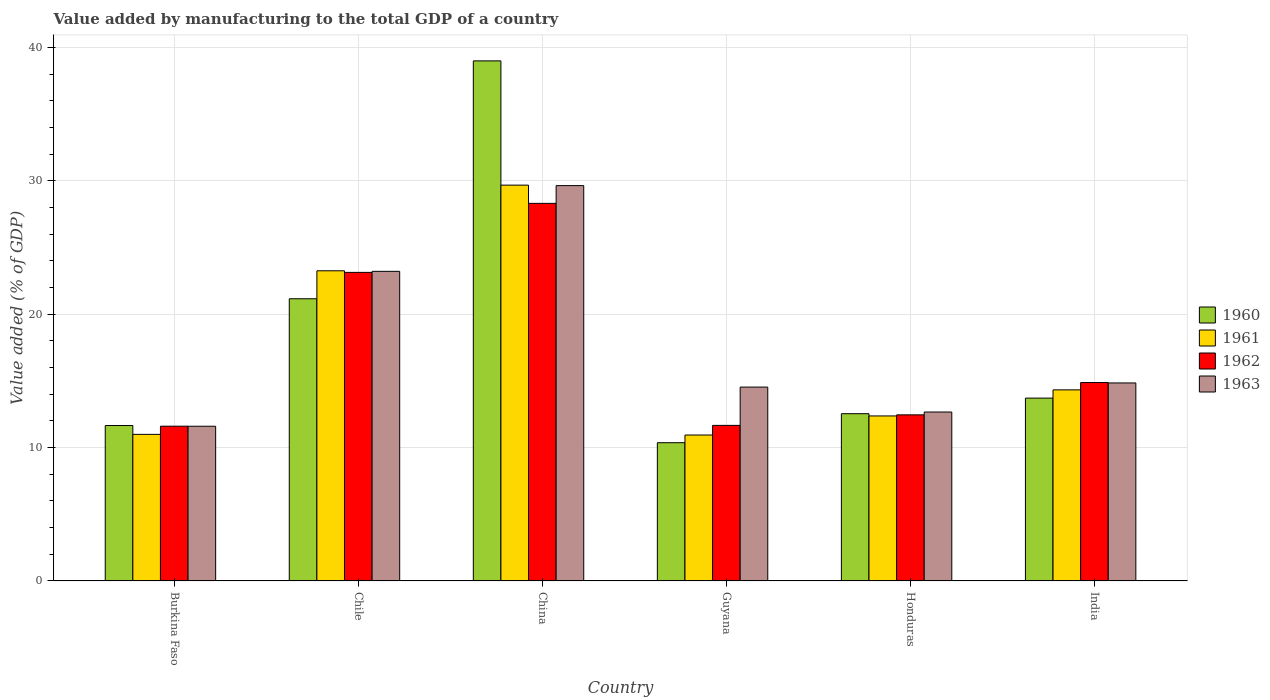How many different coloured bars are there?
Provide a short and direct response. 4. How many groups of bars are there?
Provide a succinct answer. 6. What is the label of the 1st group of bars from the left?
Give a very brief answer. Burkina Faso. What is the value added by manufacturing to the total GDP in 1963 in Burkina Faso?
Your answer should be very brief. 11.6. Across all countries, what is the maximum value added by manufacturing to the total GDP in 1963?
Your answer should be compact. 29.64. Across all countries, what is the minimum value added by manufacturing to the total GDP in 1962?
Offer a terse response. 11.6. In which country was the value added by manufacturing to the total GDP in 1961 minimum?
Offer a very short reply. Guyana. What is the total value added by manufacturing to the total GDP in 1960 in the graph?
Make the answer very short. 108.43. What is the difference between the value added by manufacturing to the total GDP in 1961 in Chile and that in Guyana?
Provide a succinct answer. 12.32. What is the difference between the value added by manufacturing to the total GDP in 1961 in Guyana and the value added by manufacturing to the total GDP in 1963 in India?
Provide a succinct answer. -3.91. What is the average value added by manufacturing to the total GDP in 1961 per country?
Make the answer very short. 16.93. What is the difference between the value added by manufacturing to the total GDP of/in 1963 and value added by manufacturing to the total GDP of/in 1960 in Burkina Faso?
Your answer should be very brief. -0.05. In how many countries, is the value added by manufacturing to the total GDP in 1962 greater than 14 %?
Provide a succinct answer. 3. What is the ratio of the value added by manufacturing to the total GDP in 1962 in Burkina Faso to that in Honduras?
Offer a very short reply. 0.93. Is the difference between the value added by manufacturing to the total GDP in 1963 in Burkina Faso and China greater than the difference between the value added by manufacturing to the total GDP in 1960 in Burkina Faso and China?
Make the answer very short. Yes. What is the difference between the highest and the second highest value added by manufacturing to the total GDP in 1963?
Your response must be concise. 14.8. What is the difference between the highest and the lowest value added by manufacturing to the total GDP in 1961?
Make the answer very short. 18.74. In how many countries, is the value added by manufacturing to the total GDP in 1962 greater than the average value added by manufacturing to the total GDP in 1962 taken over all countries?
Your answer should be compact. 2. Is the sum of the value added by manufacturing to the total GDP in 1963 in Burkina Faso and India greater than the maximum value added by manufacturing to the total GDP in 1960 across all countries?
Make the answer very short. No. Is it the case that in every country, the sum of the value added by manufacturing to the total GDP in 1962 and value added by manufacturing to the total GDP in 1963 is greater than the sum of value added by manufacturing to the total GDP in 1960 and value added by manufacturing to the total GDP in 1961?
Provide a succinct answer. No. What does the 2nd bar from the left in Burkina Faso represents?
Offer a very short reply. 1961. What does the 3rd bar from the right in Honduras represents?
Keep it short and to the point. 1961. Is it the case that in every country, the sum of the value added by manufacturing to the total GDP in 1960 and value added by manufacturing to the total GDP in 1961 is greater than the value added by manufacturing to the total GDP in 1962?
Your answer should be compact. Yes. How many bars are there?
Make the answer very short. 24. What is the difference between two consecutive major ticks on the Y-axis?
Ensure brevity in your answer.  10. Are the values on the major ticks of Y-axis written in scientific E-notation?
Ensure brevity in your answer.  No. Where does the legend appear in the graph?
Give a very brief answer. Center right. How many legend labels are there?
Offer a very short reply. 4. How are the legend labels stacked?
Offer a very short reply. Vertical. What is the title of the graph?
Your response must be concise. Value added by manufacturing to the total GDP of a country. What is the label or title of the X-axis?
Ensure brevity in your answer.  Country. What is the label or title of the Y-axis?
Keep it short and to the point. Value added (% of GDP). What is the Value added (% of GDP) in 1960 in Burkina Faso?
Ensure brevity in your answer.  11.65. What is the Value added (% of GDP) of 1961 in Burkina Faso?
Keep it short and to the point. 10.99. What is the Value added (% of GDP) of 1962 in Burkina Faso?
Give a very brief answer. 11.6. What is the Value added (% of GDP) of 1963 in Burkina Faso?
Your answer should be compact. 11.6. What is the Value added (% of GDP) in 1960 in Chile?
Ensure brevity in your answer.  21.16. What is the Value added (% of GDP) in 1961 in Chile?
Offer a terse response. 23.26. What is the Value added (% of GDP) of 1962 in Chile?
Your response must be concise. 23.14. What is the Value added (% of GDP) in 1963 in Chile?
Your answer should be very brief. 23.22. What is the Value added (% of GDP) of 1960 in China?
Your answer should be very brief. 39. What is the Value added (% of GDP) of 1961 in China?
Provide a short and direct response. 29.68. What is the Value added (% of GDP) of 1962 in China?
Provide a succinct answer. 28.31. What is the Value added (% of GDP) of 1963 in China?
Your answer should be very brief. 29.64. What is the Value added (% of GDP) of 1960 in Guyana?
Give a very brief answer. 10.37. What is the Value added (% of GDP) of 1961 in Guyana?
Give a very brief answer. 10.94. What is the Value added (% of GDP) of 1962 in Guyana?
Your answer should be compact. 11.66. What is the Value added (% of GDP) in 1963 in Guyana?
Give a very brief answer. 14.54. What is the Value added (% of GDP) of 1960 in Honduras?
Give a very brief answer. 12.54. What is the Value added (% of GDP) of 1961 in Honduras?
Offer a terse response. 12.37. What is the Value added (% of GDP) in 1962 in Honduras?
Your answer should be very brief. 12.45. What is the Value added (% of GDP) in 1963 in Honduras?
Offer a very short reply. 12.67. What is the Value added (% of GDP) in 1960 in India?
Give a very brief answer. 13.71. What is the Value added (% of GDP) of 1961 in India?
Give a very brief answer. 14.33. What is the Value added (% of GDP) of 1962 in India?
Provide a short and direct response. 14.88. What is the Value added (% of GDP) of 1963 in India?
Keep it short and to the point. 14.85. Across all countries, what is the maximum Value added (% of GDP) of 1960?
Keep it short and to the point. 39. Across all countries, what is the maximum Value added (% of GDP) of 1961?
Provide a short and direct response. 29.68. Across all countries, what is the maximum Value added (% of GDP) in 1962?
Your response must be concise. 28.31. Across all countries, what is the maximum Value added (% of GDP) in 1963?
Offer a terse response. 29.64. Across all countries, what is the minimum Value added (% of GDP) of 1960?
Make the answer very short. 10.37. Across all countries, what is the minimum Value added (% of GDP) of 1961?
Make the answer very short. 10.94. Across all countries, what is the minimum Value added (% of GDP) in 1962?
Your answer should be very brief. 11.6. Across all countries, what is the minimum Value added (% of GDP) of 1963?
Ensure brevity in your answer.  11.6. What is the total Value added (% of GDP) in 1960 in the graph?
Your answer should be compact. 108.43. What is the total Value added (% of GDP) in 1961 in the graph?
Provide a short and direct response. 101.57. What is the total Value added (% of GDP) in 1962 in the graph?
Keep it short and to the point. 102.05. What is the total Value added (% of GDP) in 1963 in the graph?
Keep it short and to the point. 106.51. What is the difference between the Value added (% of GDP) of 1960 in Burkina Faso and that in Chile?
Provide a succinct answer. -9.51. What is the difference between the Value added (% of GDP) in 1961 in Burkina Faso and that in Chile?
Offer a terse response. -12.27. What is the difference between the Value added (% of GDP) in 1962 in Burkina Faso and that in Chile?
Make the answer very short. -11.53. What is the difference between the Value added (% of GDP) in 1963 in Burkina Faso and that in Chile?
Your answer should be very brief. -11.62. What is the difference between the Value added (% of GDP) of 1960 in Burkina Faso and that in China?
Your response must be concise. -27.34. What is the difference between the Value added (% of GDP) in 1961 in Burkina Faso and that in China?
Your answer should be compact. -18.69. What is the difference between the Value added (% of GDP) in 1962 in Burkina Faso and that in China?
Offer a very short reply. -16.71. What is the difference between the Value added (% of GDP) in 1963 in Burkina Faso and that in China?
Provide a short and direct response. -18.04. What is the difference between the Value added (% of GDP) of 1960 in Burkina Faso and that in Guyana?
Make the answer very short. 1.29. What is the difference between the Value added (% of GDP) of 1961 in Burkina Faso and that in Guyana?
Keep it short and to the point. 0.05. What is the difference between the Value added (% of GDP) of 1962 in Burkina Faso and that in Guyana?
Provide a succinct answer. -0.06. What is the difference between the Value added (% of GDP) of 1963 in Burkina Faso and that in Guyana?
Your answer should be very brief. -2.94. What is the difference between the Value added (% of GDP) of 1960 in Burkina Faso and that in Honduras?
Make the answer very short. -0.89. What is the difference between the Value added (% of GDP) in 1961 in Burkina Faso and that in Honduras?
Provide a short and direct response. -1.38. What is the difference between the Value added (% of GDP) in 1962 in Burkina Faso and that in Honduras?
Make the answer very short. -0.85. What is the difference between the Value added (% of GDP) in 1963 in Burkina Faso and that in Honduras?
Offer a terse response. -1.07. What is the difference between the Value added (% of GDP) in 1960 in Burkina Faso and that in India?
Offer a very short reply. -2.06. What is the difference between the Value added (% of GDP) in 1961 in Burkina Faso and that in India?
Ensure brevity in your answer.  -3.34. What is the difference between the Value added (% of GDP) of 1962 in Burkina Faso and that in India?
Offer a very short reply. -3.27. What is the difference between the Value added (% of GDP) in 1963 in Burkina Faso and that in India?
Offer a very short reply. -3.25. What is the difference between the Value added (% of GDP) in 1960 in Chile and that in China?
Your answer should be very brief. -17.84. What is the difference between the Value added (% of GDP) of 1961 in Chile and that in China?
Your response must be concise. -6.42. What is the difference between the Value added (% of GDP) in 1962 in Chile and that in China?
Your response must be concise. -5.17. What is the difference between the Value added (% of GDP) in 1963 in Chile and that in China?
Make the answer very short. -6.43. What is the difference between the Value added (% of GDP) in 1960 in Chile and that in Guyana?
Your answer should be compact. 10.79. What is the difference between the Value added (% of GDP) of 1961 in Chile and that in Guyana?
Your answer should be very brief. 12.32. What is the difference between the Value added (% of GDP) in 1962 in Chile and that in Guyana?
Your answer should be very brief. 11.47. What is the difference between the Value added (% of GDP) of 1963 in Chile and that in Guyana?
Ensure brevity in your answer.  8.68. What is the difference between the Value added (% of GDP) in 1960 in Chile and that in Honduras?
Offer a very short reply. 8.62. What is the difference between the Value added (% of GDP) of 1961 in Chile and that in Honduras?
Give a very brief answer. 10.88. What is the difference between the Value added (% of GDP) of 1962 in Chile and that in Honduras?
Offer a very short reply. 10.68. What is the difference between the Value added (% of GDP) in 1963 in Chile and that in Honduras?
Your answer should be compact. 10.55. What is the difference between the Value added (% of GDP) of 1960 in Chile and that in India?
Offer a terse response. 7.45. What is the difference between the Value added (% of GDP) of 1961 in Chile and that in India?
Your answer should be compact. 8.93. What is the difference between the Value added (% of GDP) in 1962 in Chile and that in India?
Your answer should be compact. 8.26. What is the difference between the Value added (% of GDP) in 1963 in Chile and that in India?
Your response must be concise. 8.37. What is the difference between the Value added (% of GDP) in 1960 in China and that in Guyana?
Offer a very short reply. 28.63. What is the difference between the Value added (% of GDP) of 1961 in China and that in Guyana?
Provide a short and direct response. 18.74. What is the difference between the Value added (% of GDP) in 1962 in China and that in Guyana?
Offer a very short reply. 16.65. What is the difference between the Value added (% of GDP) in 1963 in China and that in Guyana?
Ensure brevity in your answer.  15.11. What is the difference between the Value added (% of GDP) in 1960 in China and that in Honduras?
Your response must be concise. 26.46. What is the difference between the Value added (% of GDP) of 1961 in China and that in Honduras?
Give a very brief answer. 17.31. What is the difference between the Value added (% of GDP) of 1962 in China and that in Honduras?
Offer a very short reply. 15.86. What is the difference between the Value added (% of GDP) in 1963 in China and that in Honduras?
Offer a very short reply. 16.98. What is the difference between the Value added (% of GDP) of 1960 in China and that in India?
Ensure brevity in your answer.  25.29. What is the difference between the Value added (% of GDP) of 1961 in China and that in India?
Ensure brevity in your answer.  15.35. What is the difference between the Value added (% of GDP) of 1962 in China and that in India?
Offer a terse response. 13.43. What is the difference between the Value added (% of GDP) of 1963 in China and that in India?
Provide a succinct answer. 14.8. What is the difference between the Value added (% of GDP) in 1960 in Guyana and that in Honduras?
Make the answer very short. -2.18. What is the difference between the Value added (% of GDP) in 1961 in Guyana and that in Honduras?
Give a very brief answer. -1.43. What is the difference between the Value added (% of GDP) in 1962 in Guyana and that in Honduras?
Give a very brief answer. -0.79. What is the difference between the Value added (% of GDP) in 1963 in Guyana and that in Honduras?
Make the answer very short. 1.87. What is the difference between the Value added (% of GDP) of 1960 in Guyana and that in India?
Make the answer very short. -3.34. What is the difference between the Value added (% of GDP) in 1961 in Guyana and that in India?
Offer a terse response. -3.39. What is the difference between the Value added (% of GDP) in 1962 in Guyana and that in India?
Give a very brief answer. -3.21. What is the difference between the Value added (% of GDP) of 1963 in Guyana and that in India?
Your answer should be very brief. -0.31. What is the difference between the Value added (% of GDP) in 1960 in Honduras and that in India?
Your answer should be compact. -1.17. What is the difference between the Value added (% of GDP) of 1961 in Honduras and that in India?
Offer a terse response. -1.96. What is the difference between the Value added (% of GDP) in 1962 in Honduras and that in India?
Your response must be concise. -2.42. What is the difference between the Value added (% of GDP) of 1963 in Honduras and that in India?
Your answer should be very brief. -2.18. What is the difference between the Value added (% of GDP) of 1960 in Burkina Faso and the Value added (% of GDP) of 1961 in Chile?
Your answer should be very brief. -11.6. What is the difference between the Value added (% of GDP) of 1960 in Burkina Faso and the Value added (% of GDP) of 1962 in Chile?
Make the answer very short. -11.48. What is the difference between the Value added (% of GDP) of 1960 in Burkina Faso and the Value added (% of GDP) of 1963 in Chile?
Ensure brevity in your answer.  -11.56. What is the difference between the Value added (% of GDP) of 1961 in Burkina Faso and the Value added (% of GDP) of 1962 in Chile?
Your answer should be very brief. -12.15. What is the difference between the Value added (% of GDP) in 1961 in Burkina Faso and the Value added (% of GDP) in 1963 in Chile?
Offer a very short reply. -12.23. What is the difference between the Value added (% of GDP) of 1962 in Burkina Faso and the Value added (% of GDP) of 1963 in Chile?
Give a very brief answer. -11.61. What is the difference between the Value added (% of GDP) in 1960 in Burkina Faso and the Value added (% of GDP) in 1961 in China?
Provide a short and direct response. -18.03. What is the difference between the Value added (% of GDP) in 1960 in Burkina Faso and the Value added (% of GDP) in 1962 in China?
Provide a succinct answer. -16.66. What is the difference between the Value added (% of GDP) of 1960 in Burkina Faso and the Value added (% of GDP) of 1963 in China?
Give a very brief answer. -17.99. What is the difference between the Value added (% of GDP) in 1961 in Burkina Faso and the Value added (% of GDP) in 1962 in China?
Provide a short and direct response. -17.32. What is the difference between the Value added (% of GDP) in 1961 in Burkina Faso and the Value added (% of GDP) in 1963 in China?
Provide a short and direct response. -18.65. What is the difference between the Value added (% of GDP) in 1962 in Burkina Faso and the Value added (% of GDP) in 1963 in China?
Your response must be concise. -18.04. What is the difference between the Value added (% of GDP) of 1960 in Burkina Faso and the Value added (% of GDP) of 1961 in Guyana?
Ensure brevity in your answer.  0.71. What is the difference between the Value added (% of GDP) of 1960 in Burkina Faso and the Value added (% of GDP) of 1962 in Guyana?
Keep it short and to the point. -0.01. What is the difference between the Value added (% of GDP) of 1960 in Burkina Faso and the Value added (% of GDP) of 1963 in Guyana?
Your answer should be very brief. -2.88. What is the difference between the Value added (% of GDP) in 1961 in Burkina Faso and the Value added (% of GDP) in 1962 in Guyana?
Offer a very short reply. -0.67. What is the difference between the Value added (% of GDP) in 1961 in Burkina Faso and the Value added (% of GDP) in 1963 in Guyana?
Ensure brevity in your answer.  -3.55. What is the difference between the Value added (% of GDP) in 1962 in Burkina Faso and the Value added (% of GDP) in 1963 in Guyana?
Your answer should be very brief. -2.93. What is the difference between the Value added (% of GDP) in 1960 in Burkina Faso and the Value added (% of GDP) in 1961 in Honduras?
Provide a short and direct response. -0.72. What is the difference between the Value added (% of GDP) of 1960 in Burkina Faso and the Value added (% of GDP) of 1962 in Honduras?
Offer a terse response. -0.8. What is the difference between the Value added (% of GDP) in 1960 in Burkina Faso and the Value added (% of GDP) in 1963 in Honduras?
Your answer should be compact. -1.01. What is the difference between the Value added (% of GDP) of 1961 in Burkina Faso and the Value added (% of GDP) of 1962 in Honduras?
Make the answer very short. -1.46. What is the difference between the Value added (% of GDP) of 1961 in Burkina Faso and the Value added (% of GDP) of 1963 in Honduras?
Make the answer very short. -1.68. What is the difference between the Value added (% of GDP) of 1962 in Burkina Faso and the Value added (% of GDP) of 1963 in Honduras?
Give a very brief answer. -1.06. What is the difference between the Value added (% of GDP) in 1960 in Burkina Faso and the Value added (% of GDP) in 1961 in India?
Give a very brief answer. -2.67. What is the difference between the Value added (% of GDP) in 1960 in Burkina Faso and the Value added (% of GDP) in 1962 in India?
Make the answer very short. -3.22. What is the difference between the Value added (% of GDP) of 1960 in Burkina Faso and the Value added (% of GDP) of 1963 in India?
Keep it short and to the point. -3.19. What is the difference between the Value added (% of GDP) of 1961 in Burkina Faso and the Value added (% of GDP) of 1962 in India?
Ensure brevity in your answer.  -3.89. What is the difference between the Value added (% of GDP) in 1961 in Burkina Faso and the Value added (% of GDP) in 1963 in India?
Give a very brief answer. -3.86. What is the difference between the Value added (% of GDP) in 1962 in Burkina Faso and the Value added (% of GDP) in 1963 in India?
Provide a succinct answer. -3.24. What is the difference between the Value added (% of GDP) in 1960 in Chile and the Value added (% of GDP) in 1961 in China?
Ensure brevity in your answer.  -8.52. What is the difference between the Value added (% of GDP) of 1960 in Chile and the Value added (% of GDP) of 1962 in China?
Your answer should be very brief. -7.15. What is the difference between the Value added (% of GDP) in 1960 in Chile and the Value added (% of GDP) in 1963 in China?
Provide a succinct answer. -8.48. What is the difference between the Value added (% of GDP) in 1961 in Chile and the Value added (% of GDP) in 1962 in China?
Offer a terse response. -5.06. What is the difference between the Value added (% of GDP) of 1961 in Chile and the Value added (% of GDP) of 1963 in China?
Provide a succinct answer. -6.39. What is the difference between the Value added (% of GDP) in 1962 in Chile and the Value added (% of GDP) in 1963 in China?
Your response must be concise. -6.51. What is the difference between the Value added (% of GDP) of 1960 in Chile and the Value added (% of GDP) of 1961 in Guyana?
Your answer should be compact. 10.22. What is the difference between the Value added (% of GDP) in 1960 in Chile and the Value added (% of GDP) in 1962 in Guyana?
Your answer should be compact. 9.5. What is the difference between the Value added (% of GDP) of 1960 in Chile and the Value added (% of GDP) of 1963 in Guyana?
Make the answer very short. 6.62. What is the difference between the Value added (% of GDP) in 1961 in Chile and the Value added (% of GDP) in 1962 in Guyana?
Offer a very short reply. 11.59. What is the difference between the Value added (% of GDP) of 1961 in Chile and the Value added (% of GDP) of 1963 in Guyana?
Your answer should be very brief. 8.72. What is the difference between the Value added (% of GDP) in 1962 in Chile and the Value added (% of GDP) in 1963 in Guyana?
Ensure brevity in your answer.  8.6. What is the difference between the Value added (% of GDP) in 1960 in Chile and the Value added (% of GDP) in 1961 in Honduras?
Provide a short and direct response. 8.79. What is the difference between the Value added (% of GDP) of 1960 in Chile and the Value added (% of GDP) of 1962 in Honduras?
Give a very brief answer. 8.71. What is the difference between the Value added (% of GDP) of 1960 in Chile and the Value added (% of GDP) of 1963 in Honduras?
Ensure brevity in your answer.  8.49. What is the difference between the Value added (% of GDP) in 1961 in Chile and the Value added (% of GDP) in 1962 in Honduras?
Offer a terse response. 10.8. What is the difference between the Value added (% of GDP) of 1961 in Chile and the Value added (% of GDP) of 1963 in Honduras?
Your response must be concise. 10.59. What is the difference between the Value added (% of GDP) in 1962 in Chile and the Value added (% of GDP) in 1963 in Honduras?
Offer a terse response. 10.47. What is the difference between the Value added (% of GDP) in 1960 in Chile and the Value added (% of GDP) in 1961 in India?
Keep it short and to the point. 6.83. What is the difference between the Value added (% of GDP) of 1960 in Chile and the Value added (% of GDP) of 1962 in India?
Offer a terse response. 6.28. What is the difference between the Value added (% of GDP) of 1960 in Chile and the Value added (% of GDP) of 1963 in India?
Make the answer very short. 6.31. What is the difference between the Value added (% of GDP) in 1961 in Chile and the Value added (% of GDP) in 1962 in India?
Ensure brevity in your answer.  8.38. What is the difference between the Value added (% of GDP) in 1961 in Chile and the Value added (% of GDP) in 1963 in India?
Provide a succinct answer. 8.41. What is the difference between the Value added (% of GDP) of 1962 in Chile and the Value added (% of GDP) of 1963 in India?
Keep it short and to the point. 8.29. What is the difference between the Value added (% of GDP) in 1960 in China and the Value added (% of GDP) in 1961 in Guyana?
Make the answer very short. 28.06. What is the difference between the Value added (% of GDP) in 1960 in China and the Value added (% of GDP) in 1962 in Guyana?
Your answer should be very brief. 27.33. What is the difference between the Value added (% of GDP) of 1960 in China and the Value added (% of GDP) of 1963 in Guyana?
Provide a succinct answer. 24.46. What is the difference between the Value added (% of GDP) of 1961 in China and the Value added (% of GDP) of 1962 in Guyana?
Provide a succinct answer. 18.02. What is the difference between the Value added (% of GDP) of 1961 in China and the Value added (% of GDP) of 1963 in Guyana?
Give a very brief answer. 15.14. What is the difference between the Value added (% of GDP) in 1962 in China and the Value added (% of GDP) in 1963 in Guyana?
Your answer should be very brief. 13.78. What is the difference between the Value added (% of GDP) in 1960 in China and the Value added (% of GDP) in 1961 in Honduras?
Give a very brief answer. 26.63. What is the difference between the Value added (% of GDP) in 1960 in China and the Value added (% of GDP) in 1962 in Honduras?
Provide a short and direct response. 26.54. What is the difference between the Value added (% of GDP) in 1960 in China and the Value added (% of GDP) in 1963 in Honduras?
Your response must be concise. 26.33. What is the difference between the Value added (% of GDP) of 1961 in China and the Value added (% of GDP) of 1962 in Honduras?
Ensure brevity in your answer.  17.23. What is the difference between the Value added (% of GDP) of 1961 in China and the Value added (% of GDP) of 1963 in Honduras?
Provide a short and direct response. 17.01. What is the difference between the Value added (% of GDP) in 1962 in China and the Value added (% of GDP) in 1963 in Honduras?
Make the answer very short. 15.65. What is the difference between the Value added (% of GDP) in 1960 in China and the Value added (% of GDP) in 1961 in India?
Your answer should be very brief. 24.67. What is the difference between the Value added (% of GDP) of 1960 in China and the Value added (% of GDP) of 1962 in India?
Provide a short and direct response. 24.12. What is the difference between the Value added (% of GDP) of 1960 in China and the Value added (% of GDP) of 1963 in India?
Offer a terse response. 24.15. What is the difference between the Value added (% of GDP) of 1961 in China and the Value added (% of GDP) of 1962 in India?
Make the answer very short. 14.8. What is the difference between the Value added (% of GDP) in 1961 in China and the Value added (% of GDP) in 1963 in India?
Make the answer very short. 14.83. What is the difference between the Value added (% of GDP) in 1962 in China and the Value added (% of GDP) in 1963 in India?
Your response must be concise. 13.47. What is the difference between the Value added (% of GDP) of 1960 in Guyana and the Value added (% of GDP) of 1961 in Honduras?
Keep it short and to the point. -2.01. What is the difference between the Value added (% of GDP) of 1960 in Guyana and the Value added (% of GDP) of 1962 in Honduras?
Provide a short and direct response. -2.09. What is the difference between the Value added (% of GDP) in 1960 in Guyana and the Value added (% of GDP) in 1963 in Honduras?
Offer a very short reply. -2.3. What is the difference between the Value added (% of GDP) in 1961 in Guyana and the Value added (% of GDP) in 1962 in Honduras?
Ensure brevity in your answer.  -1.51. What is the difference between the Value added (% of GDP) in 1961 in Guyana and the Value added (% of GDP) in 1963 in Honduras?
Your response must be concise. -1.73. What is the difference between the Value added (% of GDP) of 1962 in Guyana and the Value added (% of GDP) of 1963 in Honduras?
Ensure brevity in your answer.  -1. What is the difference between the Value added (% of GDP) of 1960 in Guyana and the Value added (% of GDP) of 1961 in India?
Your response must be concise. -3.96. What is the difference between the Value added (% of GDP) in 1960 in Guyana and the Value added (% of GDP) in 1962 in India?
Your answer should be very brief. -4.51. What is the difference between the Value added (% of GDP) in 1960 in Guyana and the Value added (% of GDP) in 1963 in India?
Ensure brevity in your answer.  -4.48. What is the difference between the Value added (% of GDP) in 1961 in Guyana and the Value added (% of GDP) in 1962 in India?
Keep it short and to the point. -3.94. What is the difference between the Value added (% of GDP) in 1961 in Guyana and the Value added (% of GDP) in 1963 in India?
Your response must be concise. -3.91. What is the difference between the Value added (% of GDP) in 1962 in Guyana and the Value added (% of GDP) in 1963 in India?
Make the answer very short. -3.18. What is the difference between the Value added (% of GDP) in 1960 in Honduras and the Value added (% of GDP) in 1961 in India?
Your response must be concise. -1.79. What is the difference between the Value added (% of GDP) of 1960 in Honduras and the Value added (% of GDP) of 1962 in India?
Provide a succinct answer. -2.34. What is the difference between the Value added (% of GDP) in 1960 in Honduras and the Value added (% of GDP) in 1963 in India?
Make the answer very short. -2.31. What is the difference between the Value added (% of GDP) in 1961 in Honduras and the Value added (% of GDP) in 1962 in India?
Offer a terse response. -2.51. What is the difference between the Value added (% of GDP) of 1961 in Honduras and the Value added (% of GDP) of 1963 in India?
Provide a succinct answer. -2.47. What is the difference between the Value added (% of GDP) in 1962 in Honduras and the Value added (% of GDP) in 1963 in India?
Offer a very short reply. -2.39. What is the average Value added (% of GDP) of 1960 per country?
Keep it short and to the point. 18.07. What is the average Value added (% of GDP) of 1961 per country?
Provide a short and direct response. 16.93. What is the average Value added (% of GDP) in 1962 per country?
Provide a succinct answer. 17.01. What is the average Value added (% of GDP) in 1963 per country?
Provide a succinct answer. 17.75. What is the difference between the Value added (% of GDP) in 1960 and Value added (% of GDP) in 1961 in Burkina Faso?
Offer a very short reply. 0.66. What is the difference between the Value added (% of GDP) of 1960 and Value added (% of GDP) of 1962 in Burkina Faso?
Your response must be concise. 0.05. What is the difference between the Value added (% of GDP) of 1960 and Value added (% of GDP) of 1963 in Burkina Faso?
Your answer should be very brief. 0.05. What is the difference between the Value added (% of GDP) of 1961 and Value added (% of GDP) of 1962 in Burkina Faso?
Give a very brief answer. -0.61. What is the difference between the Value added (% of GDP) in 1961 and Value added (% of GDP) in 1963 in Burkina Faso?
Your response must be concise. -0.61. What is the difference between the Value added (% of GDP) of 1962 and Value added (% of GDP) of 1963 in Burkina Faso?
Your response must be concise. 0. What is the difference between the Value added (% of GDP) in 1960 and Value added (% of GDP) in 1961 in Chile?
Offer a terse response. -2.1. What is the difference between the Value added (% of GDP) in 1960 and Value added (% of GDP) in 1962 in Chile?
Offer a very short reply. -1.98. What is the difference between the Value added (% of GDP) of 1960 and Value added (% of GDP) of 1963 in Chile?
Offer a very short reply. -2.06. What is the difference between the Value added (% of GDP) in 1961 and Value added (% of GDP) in 1962 in Chile?
Ensure brevity in your answer.  0.12. What is the difference between the Value added (% of GDP) in 1961 and Value added (% of GDP) in 1963 in Chile?
Keep it short and to the point. 0.04. What is the difference between the Value added (% of GDP) in 1962 and Value added (% of GDP) in 1963 in Chile?
Ensure brevity in your answer.  -0.08. What is the difference between the Value added (% of GDP) of 1960 and Value added (% of GDP) of 1961 in China?
Offer a terse response. 9.32. What is the difference between the Value added (% of GDP) of 1960 and Value added (% of GDP) of 1962 in China?
Offer a very short reply. 10.69. What is the difference between the Value added (% of GDP) of 1960 and Value added (% of GDP) of 1963 in China?
Your response must be concise. 9.35. What is the difference between the Value added (% of GDP) in 1961 and Value added (% of GDP) in 1962 in China?
Ensure brevity in your answer.  1.37. What is the difference between the Value added (% of GDP) in 1961 and Value added (% of GDP) in 1963 in China?
Offer a very short reply. 0.04. What is the difference between the Value added (% of GDP) in 1962 and Value added (% of GDP) in 1963 in China?
Give a very brief answer. -1.33. What is the difference between the Value added (% of GDP) in 1960 and Value added (% of GDP) in 1961 in Guyana?
Provide a succinct answer. -0.58. What is the difference between the Value added (% of GDP) in 1960 and Value added (% of GDP) in 1962 in Guyana?
Provide a short and direct response. -1.3. What is the difference between the Value added (% of GDP) of 1960 and Value added (% of GDP) of 1963 in Guyana?
Offer a terse response. -4.17. What is the difference between the Value added (% of GDP) of 1961 and Value added (% of GDP) of 1962 in Guyana?
Provide a short and direct response. -0.72. What is the difference between the Value added (% of GDP) in 1961 and Value added (% of GDP) in 1963 in Guyana?
Your response must be concise. -3.6. What is the difference between the Value added (% of GDP) of 1962 and Value added (% of GDP) of 1963 in Guyana?
Your answer should be very brief. -2.87. What is the difference between the Value added (% of GDP) of 1960 and Value added (% of GDP) of 1961 in Honduras?
Keep it short and to the point. 0.17. What is the difference between the Value added (% of GDP) of 1960 and Value added (% of GDP) of 1962 in Honduras?
Offer a very short reply. 0.09. What is the difference between the Value added (% of GDP) in 1960 and Value added (% of GDP) in 1963 in Honduras?
Offer a terse response. -0.13. What is the difference between the Value added (% of GDP) of 1961 and Value added (% of GDP) of 1962 in Honduras?
Keep it short and to the point. -0.08. What is the difference between the Value added (% of GDP) of 1961 and Value added (% of GDP) of 1963 in Honduras?
Ensure brevity in your answer.  -0.29. What is the difference between the Value added (% of GDP) in 1962 and Value added (% of GDP) in 1963 in Honduras?
Your response must be concise. -0.21. What is the difference between the Value added (% of GDP) of 1960 and Value added (% of GDP) of 1961 in India?
Your answer should be compact. -0.62. What is the difference between the Value added (% of GDP) of 1960 and Value added (% of GDP) of 1962 in India?
Provide a short and direct response. -1.17. What is the difference between the Value added (% of GDP) in 1960 and Value added (% of GDP) in 1963 in India?
Ensure brevity in your answer.  -1.14. What is the difference between the Value added (% of GDP) of 1961 and Value added (% of GDP) of 1962 in India?
Offer a terse response. -0.55. What is the difference between the Value added (% of GDP) of 1961 and Value added (% of GDP) of 1963 in India?
Ensure brevity in your answer.  -0.52. What is the difference between the Value added (% of GDP) in 1962 and Value added (% of GDP) in 1963 in India?
Give a very brief answer. 0.03. What is the ratio of the Value added (% of GDP) of 1960 in Burkina Faso to that in Chile?
Offer a terse response. 0.55. What is the ratio of the Value added (% of GDP) of 1961 in Burkina Faso to that in Chile?
Keep it short and to the point. 0.47. What is the ratio of the Value added (% of GDP) in 1962 in Burkina Faso to that in Chile?
Provide a short and direct response. 0.5. What is the ratio of the Value added (% of GDP) in 1963 in Burkina Faso to that in Chile?
Your answer should be compact. 0.5. What is the ratio of the Value added (% of GDP) of 1960 in Burkina Faso to that in China?
Provide a succinct answer. 0.3. What is the ratio of the Value added (% of GDP) in 1961 in Burkina Faso to that in China?
Offer a very short reply. 0.37. What is the ratio of the Value added (% of GDP) of 1962 in Burkina Faso to that in China?
Your response must be concise. 0.41. What is the ratio of the Value added (% of GDP) of 1963 in Burkina Faso to that in China?
Ensure brevity in your answer.  0.39. What is the ratio of the Value added (% of GDP) of 1960 in Burkina Faso to that in Guyana?
Your answer should be very brief. 1.12. What is the ratio of the Value added (% of GDP) of 1962 in Burkina Faso to that in Guyana?
Your answer should be very brief. 0.99. What is the ratio of the Value added (% of GDP) of 1963 in Burkina Faso to that in Guyana?
Make the answer very short. 0.8. What is the ratio of the Value added (% of GDP) in 1960 in Burkina Faso to that in Honduras?
Provide a short and direct response. 0.93. What is the ratio of the Value added (% of GDP) of 1961 in Burkina Faso to that in Honduras?
Give a very brief answer. 0.89. What is the ratio of the Value added (% of GDP) of 1962 in Burkina Faso to that in Honduras?
Give a very brief answer. 0.93. What is the ratio of the Value added (% of GDP) of 1963 in Burkina Faso to that in Honduras?
Your answer should be very brief. 0.92. What is the ratio of the Value added (% of GDP) in 1960 in Burkina Faso to that in India?
Make the answer very short. 0.85. What is the ratio of the Value added (% of GDP) of 1961 in Burkina Faso to that in India?
Keep it short and to the point. 0.77. What is the ratio of the Value added (% of GDP) in 1962 in Burkina Faso to that in India?
Offer a terse response. 0.78. What is the ratio of the Value added (% of GDP) of 1963 in Burkina Faso to that in India?
Your answer should be very brief. 0.78. What is the ratio of the Value added (% of GDP) in 1960 in Chile to that in China?
Make the answer very short. 0.54. What is the ratio of the Value added (% of GDP) in 1961 in Chile to that in China?
Provide a succinct answer. 0.78. What is the ratio of the Value added (% of GDP) of 1962 in Chile to that in China?
Give a very brief answer. 0.82. What is the ratio of the Value added (% of GDP) in 1963 in Chile to that in China?
Your answer should be compact. 0.78. What is the ratio of the Value added (% of GDP) in 1960 in Chile to that in Guyana?
Offer a terse response. 2.04. What is the ratio of the Value added (% of GDP) of 1961 in Chile to that in Guyana?
Offer a terse response. 2.13. What is the ratio of the Value added (% of GDP) of 1962 in Chile to that in Guyana?
Your answer should be compact. 1.98. What is the ratio of the Value added (% of GDP) in 1963 in Chile to that in Guyana?
Your response must be concise. 1.6. What is the ratio of the Value added (% of GDP) of 1960 in Chile to that in Honduras?
Make the answer very short. 1.69. What is the ratio of the Value added (% of GDP) of 1961 in Chile to that in Honduras?
Your answer should be compact. 1.88. What is the ratio of the Value added (% of GDP) of 1962 in Chile to that in Honduras?
Offer a terse response. 1.86. What is the ratio of the Value added (% of GDP) of 1963 in Chile to that in Honduras?
Provide a succinct answer. 1.83. What is the ratio of the Value added (% of GDP) of 1960 in Chile to that in India?
Your answer should be very brief. 1.54. What is the ratio of the Value added (% of GDP) of 1961 in Chile to that in India?
Provide a short and direct response. 1.62. What is the ratio of the Value added (% of GDP) in 1962 in Chile to that in India?
Give a very brief answer. 1.56. What is the ratio of the Value added (% of GDP) in 1963 in Chile to that in India?
Keep it short and to the point. 1.56. What is the ratio of the Value added (% of GDP) in 1960 in China to that in Guyana?
Provide a short and direct response. 3.76. What is the ratio of the Value added (% of GDP) in 1961 in China to that in Guyana?
Your answer should be very brief. 2.71. What is the ratio of the Value added (% of GDP) in 1962 in China to that in Guyana?
Provide a succinct answer. 2.43. What is the ratio of the Value added (% of GDP) in 1963 in China to that in Guyana?
Give a very brief answer. 2.04. What is the ratio of the Value added (% of GDP) of 1960 in China to that in Honduras?
Your answer should be compact. 3.11. What is the ratio of the Value added (% of GDP) of 1961 in China to that in Honduras?
Your answer should be very brief. 2.4. What is the ratio of the Value added (% of GDP) of 1962 in China to that in Honduras?
Offer a terse response. 2.27. What is the ratio of the Value added (% of GDP) in 1963 in China to that in Honduras?
Offer a terse response. 2.34. What is the ratio of the Value added (% of GDP) in 1960 in China to that in India?
Your answer should be compact. 2.84. What is the ratio of the Value added (% of GDP) in 1961 in China to that in India?
Your response must be concise. 2.07. What is the ratio of the Value added (% of GDP) of 1962 in China to that in India?
Provide a short and direct response. 1.9. What is the ratio of the Value added (% of GDP) of 1963 in China to that in India?
Offer a terse response. 2. What is the ratio of the Value added (% of GDP) in 1960 in Guyana to that in Honduras?
Provide a succinct answer. 0.83. What is the ratio of the Value added (% of GDP) in 1961 in Guyana to that in Honduras?
Your response must be concise. 0.88. What is the ratio of the Value added (% of GDP) in 1962 in Guyana to that in Honduras?
Keep it short and to the point. 0.94. What is the ratio of the Value added (% of GDP) in 1963 in Guyana to that in Honduras?
Provide a succinct answer. 1.15. What is the ratio of the Value added (% of GDP) in 1960 in Guyana to that in India?
Your answer should be very brief. 0.76. What is the ratio of the Value added (% of GDP) of 1961 in Guyana to that in India?
Give a very brief answer. 0.76. What is the ratio of the Value added (% of GDP) in 1962 in Guyana to that in India?
Ensure brevity in your answer.  0.78. What is the ratio of the Value added (% of GDP) in 1963 in Guyana to that in India?
Your answer should be compact. 0.98. What is the ratio of the Value added (% of GDP) in 1960 in Honduras to that in India?
Provide a succinct answer. 0.91. What is the ratio of the Value added (% of GDP) of 1961 in Honduras to that in India?
Your answer should be compact. 0.86. What is the ratio of the Value added (% of GDP) of 1962 in Honduras to that in India?
Keep it short and to the point. 0.84. What is the ratio of the Value added (% of GDP) in 1963 in Honduras to that in India?
Offer a very short reply. 0.85. What is the difference between the highest and the second highest Value added (% of GDP) in 1960?
Provide a succinct answer. 17.84. What is the difference between the highest and the second highest Value added (% of GDP) of 1961?
Make the answer very short. 6.42. What is the difference between the highest and the second highest Value added (% of GDP) of 1962?
Offer a terse response. 5.17. What is the difference between the highest and the second highest Value added (% of GDP) of 1963?
Keep it short and to the point. 6.43. What is the difference between the highest and the lowest Value added (% of GDP) of 1960?
Ensure brevity in your answer.  28.63. What is the difference between the highest and the lowest Value added (% of GDP) in 1961?
Keep it short and to the point. 18.74. What is the difference between the highest and the lowest Value added (% of GDP) of 1962?
Keep it short and to the point. 16.71. What is the difference between the highest and the lowest Value added (% of GDP) of 1963?
Your answer should be compact. 18.04. 